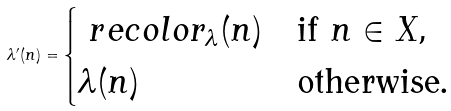Convert formula to latex. <formula><loc_0><loc_0><loc_500><loc_500>\lambda ^ { \prime } ( n ) = \begin{cases} \ r e c o l o r _ { \lambda } ( n ) & \text {if $n\in X$,} \\ \lambda ( n ) & \text {otherwise.} \end{cases}</formula> 